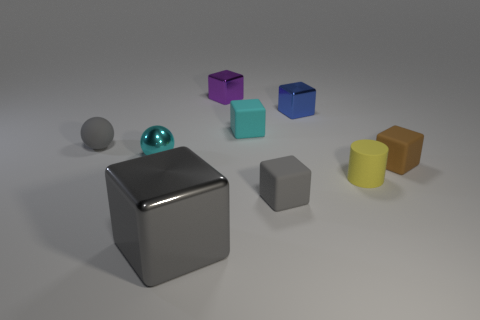Is the number of blue metallic things right of the brown rubber object greater than the number of small brown cubes to the left of the big cube?
Provide a succinct answer. No. What material is the gray thing that is on the right side of the matte cube that is behind the small rubber cube that is to the right of the small blue metal cube?
Your answer should be very brief. Rubber. There is a gray thing that is made of the same material as the small purple thing; what shape is it?
Your answer should be very brief. Cube. There is a small block right of the yellow cylinder; is there a small blue block that is in front of it?
Your response must be concise. No. How big is the gray sphere?
Provide a short and direct response. Small. How many objects are small metal cubes or matte blocks?
Your answer should be very brief. 5. Do the small cyan thing that is on the right side of the large gray metal thing and the small thing that is behind the blue metallic block have the same material?
Make the answer very short. No. The sphere that is made of the same material as the small yellow cylinder is what color?
Offer a terse response. Gray. What number of other rubber blocks are the same size as the gray rubber block?
Provide a short and direct response. 2. How many other objects are the same color as the large shiny thing?
Your answer should be compact. 2. 